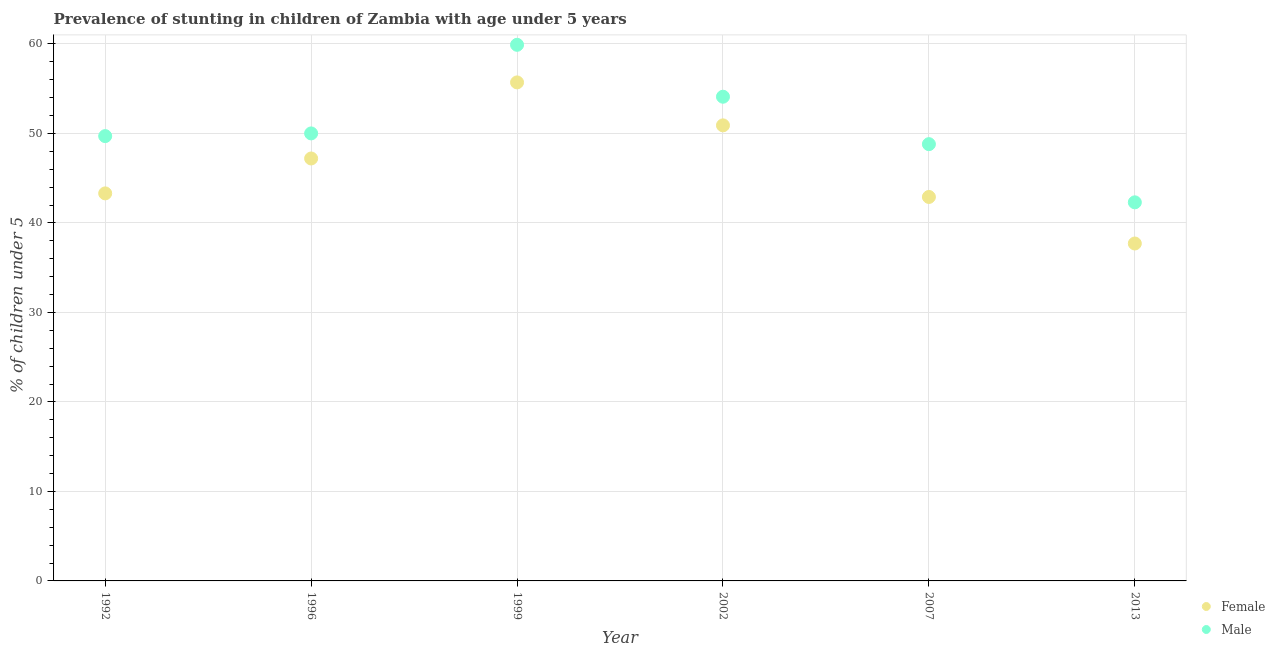How many different coloured dotlines are there?
Keep it short and to the point. 2. What is the percentage of stunted male children in 1996?
Provide a succinct answer. 50. Across all years, what is the maximum percentage of stunted male children?
Your response must be concise. 59.9. Across all years, what is the minimum percentage of stunted male children?
Keep it short and to the point. 42.3. In which year was the percentage of stunted female children maximum?
Your response must be concise. 1999. In which year was the percentage of stunted male children minimum?
Offer a terse response. 2013. What is the total percentage of stunted female children in the graph?
Provide a succinct answer. 277.7. What is the difference between the percentage of stunted female children in 1992 and that in 2002?
Offer a very short reply. -7.6. What is the difference between the percentage of stunted female children in 1999 and the percentage of stunted male children in 1992?
Your answer should be very brief. 6. What is the average percentage of stunted female children per year?
Offer a very short reply. 46.28. In the year 2007, what is the difference between the percentage of stunted male children and percentage of stunted female children?
Provide a short and direct response. 5.9. In how many years, is the percentage of stunted male children greater than 10 %?
Make the answer very short. 6. What is the ratio of the percentage of stunted male children in 1999 to that in 2013?
Keep it short and to the point. 1.42. What is the difference between the highest and the second highest percentage of stunted male children?
Provide a short and direct response. 5.8. What is the difference between the highest and the lowest percentage of stunted male children?
Provide a succinct answer. 17.6. Is the sum of the percentage of stunted female children in 2002 and 2013 greater than the maximum percentage of stunted male children across all years?
Keep it short and to the point. Yes. Does the percentage of stunted male children monotonically increase over the years?
Offer a terse response. No. Is the percentage of stunted female children strictly greater than the percentage of stunted male children over the years?
Your answer should be compact. No. What is the difference between two consecutive major ticks on the Y-axis?
Your answer should be very brief. 10. Are the values on the major ticks of Y-axis written in scientific E-notation?
Offer a terse response. No. Where does the legend appear in the graph?
Your response must be concise. Bottom right. What is the title of the graph?
Make the answer very short. Prevalence of stunting in children of Zambia with age under 5 years. What is the label or title of the Y-axis?
Offer a very short reply.  % of children under 5. What is the  % of children under 5 in Female in 1992?
Keep it short and to the point. 43.3. What is the  % of children under 5 in Male in 1992?
Your answer should be compact. 49.7. What is the  % of children under 5 in Female in 1996?
Keep it short and to the point. 47.2. What is the  % of children under 5 of Male in 1996?
Give a very brief answer. 50. What is the  % of children under 5 in Female in 1999?
Your answer should be very brief. 55.7. What is the  % of children under 5 of Male in 1999?
Your response must be concise. 59.9. What is the  % of children under 5 of Female in 2002?
Provide a succinct answer. 50.9. What is the  % of children under 5 in Male in 2002?
Offer a terse response. 54.1. What is the  % of children under 5 in Female in 2007?
Keep it short and to the point. 42.9. What is the  % of children under 5 of Male in 2007?
Make the answer very short. 48.8. What is the  % of children under 5 of Female in 2013?
Your response must be concise. 37.7. What is the  % of children under 5 in Male in 2013?
Give a very brief answer. 42.3. Across all years, what is the maximum  % of children under 5 of Female?
Give a very brief answer. 55.7. Across all years, what is the maximum  % of children under 5 of Male?
Provide a short and direct response. 59.9. Across all years, what is the minimum  % of children under 5 of Female?
Provide a succinct answer. 37.7. Across all years, what is the minimum  % of children under 5 of Male?
Make the answer very short. 42.3. What is the total  % of children under 5 of Female in the graph?
Ensure brevity in your answer.  277.7. What is the total  % of children under 5 of Male in the graph?
Offer a terse response. 304.8. What is the difference between the  % of children under 5 of Male in 1992 and that in 2002?
Offer a very short reply. -4.4. What is the difference between the  % of children under 5 of Male in 1992 and that in 2007?
Make the answer very short. 0.9. What is the difference between the  % of children under 5 of Male in 1996 and that in 1999?
Make the answer very short. -9.9. What is the difference between the  % of children under 5 of Female in 1996 and that in 2007?
Provide a succinct answer. 4.3. What is the difference between the  % of children under 5 of Female in 1996 and that in 2013?
Offer a very short reply. 9.5. What is the difference between the  % of children under 5 in Male in 1996 and that in 2013?
Your response must be concise. 7.7. What is the difference between the  % of children under 5 of Female in 1999 and that in 2002?
Your response must be concise. 4.8. What is the difference between the  % of children under 5 of Male in 1999 and that in 2002?
Offer a terse response. 5.8. What is the difference between the  % of children under 5 of Female in 1999 and that in 2007?
Give a very brief answer. 12.8. What is the difference between the  % of children under 5 in Female in 2002 and that in 2007?
Keep it short and to the point. 8. What is the difference between the  % of children under 5 of Female in 2007 and that in 2013?
Make the answer very short. 5.2. What is the difference between the  % of children under 5 in Male in 2007 and that in 2013?
Offer a terse response. 6.5. What is the difference between the  % of children under 5 in Female in 1992 and the  % of children under 5 in Male in 1999?
Offer a very short reply. -16.6. What is the difference between the  % of children under 5 of Female in 1992 and the  % of children under 5 of Male in 2002?
Your answer should be compact. -10.8. What is the difference between the  % of children under 5 in Female in 1992 and the  % of children under 5 in Male in 2007?
Your response must be concise. -5.5. What is the difference between the  % of children under 5 of Female in 1992 and the  % of children under 5 of Male in 2013?
Provide a succinct answer. 1. What is the difference between the  % of children under 5 of Female in 1996 and the  % of children under 5 of Male in 1999?
Your answer should be very brief. -12.7. What is the difference between the  % of children under 5 in Female in 1996 and the  % of children under 5 in Male in 2007?
Provide a short and direct response. -1.6. What is the difference between the  % of children under 5 in Female in 1999 and the  % of children under 5 in Male in 2002?
Provide a short and direct response. 1.6. What is the average  % of children under 5 of Female per year?
Your answer should be compact. 46.28. What is the average  % of children under 5 of Male per year?
Ensure brevity in your answer.  50.8. In the year 1996, what is the difference between the  % of children under 5 in Female and  % of children under 5 in Male?
Offer a terse response. -2.8. In the year 2002, what is the difference between the  % of children under 5 of Female and  % of children under 5 of Male?
Give a very brief answer. -3.2. In the year 2007, what is the difference between the  % of children under 5 of Female and  % of children under 5 of Male?
Your answer should be compact. -5.9. In the year 2013, what is the difference between the  % of children under 5 of Female and  % of children under 5 of Male?
Keep it short and to the point. -4.6. What is the ratio of the  % of children under 5 in Female in 1992 to that in 1996?
Your answer should be very brief. 0.92. What is the ratio of the  % of children under 5 of Female in 1992 to that in 1999?
Your answer should be very brief. 0.78. What is the ratio of the  % of children under 5 of Male in 1992 to that in 1999?
Make the answer very short. 0.83. What is the ratio of the  % of children under 5 of Female in 1992 to that in 2002?
Your answer should be very brief. 0.85. What is the ratio of the  % of children under 5 in Male in 1992 to that in 2002?
Give a very brief answer. 0.92. What is the ratio of the  % of children under 5 of Female in 1992 to that in 2007?
Ensure brevity in your answer.  1.01. What is the ratio of the  % of children under 5 in Male in 1992 to that in 2007?
Give a very brief answer. 1.02. What is the ratio of the  % of children under 5 of Female in 1992 to that in 2013?
Give a very brief answer. 1.15. What is the ratio of the  % of children under 5 in Male in 1992 to that in 2013?
Provide a short and direct response. 1.17. What is the ratio of the  % of children under 5 of Female in 1996 to that in 1999?
Offer a terse response. 0.85. What is the ratio of the  % of children under 5 of Male in 1996 to that in 1999?
Offer a very short reply. 0.83. What is the ratio of the  % of children under 5 of Female in 1996 to that in 2002?
Your answer should be very brief. 0.93. What is the ratio of the  % of children under 5 in Male in 1996 to that in 2002?
Provide a succinct answer. 0.92. What is the ratio of the  % of children under 5 in Female in 1996 to that in 2007?
Provide a succinct answer. 1.1. What is the ratio of the  % of children under 5 of Male in 1996 to that in 2007?
Keep it short and to the point. 1.02. What is the ratio of the  % of children under 5 in Female in 1996 to that in 2013?
Keep it short and to the point. 1.25. What is the ratio of the  % of children under 5 in Male in 1996 to that in 2013?
Your answer should be very brief. 1.18. What is the ratio of the  % of children under 5 of Female in 1999 to that in 2002?
Offer a very short reply. 1.09. What is the ratio of the  % of children under 5 in Male in 1999 to that in 2002?
Offer a very short reply. 1.11. What is the ratio of the  % of children under 5 in Female in 1999 to that in 2007?
Your answer should be very brief. 1.3. What is the ratio of the  % of children under 5 in Male in 1999 to that in 2007?
Keep it short and to the point. 1.23. What is the ratio of the  % of children under 5 in Female in 1999 to that in 2013?
Your answer should be very brief. 1.48. What is the ratio of the  % of children under 5 of Male in 1999 to that in 2013?
Your answer should be compact. 1.42. What is the ratio of the  % of children under 5 in Female in 2002 to that in 2007?
Your answer should be very brief. 1.19. What is the ratio of the  % of children under 5 of Male in 2002 to that in 2007?
Your answer should be very brief. 1.11. What is the ratio of the  % of children under 5 in Female in 2002 to that in 2013?
Your answer should be very brief. 1.35. What is the ratio of the  % of children under 5 in Male in 2002 to that in 2013?
Make the answer very short. 1.28. What is the ratio of the  % of children under 5 of Female in 2007 to that in 2013?
Your response must be concise. 1.14. What is the ratio of the  % of children under 5 in Male in 2007 to that in 2013?
Provide a short and direct response. 1.15. What is the difference between the highest and the second highest  % of children under 5 in Female?
Give a very brief answer. 4.8. What is the difference between the highest and the second highest  % of children under 5 of Male?
Give a very brief answer. 5.8. What is the difference between the highest and the lowest  % of children under 5 of Female?
Make the answer very short. 18. What is the difference between the highest and the lowest  % of children under 5 in Male?
Your answer should be very brief. 17.6. 